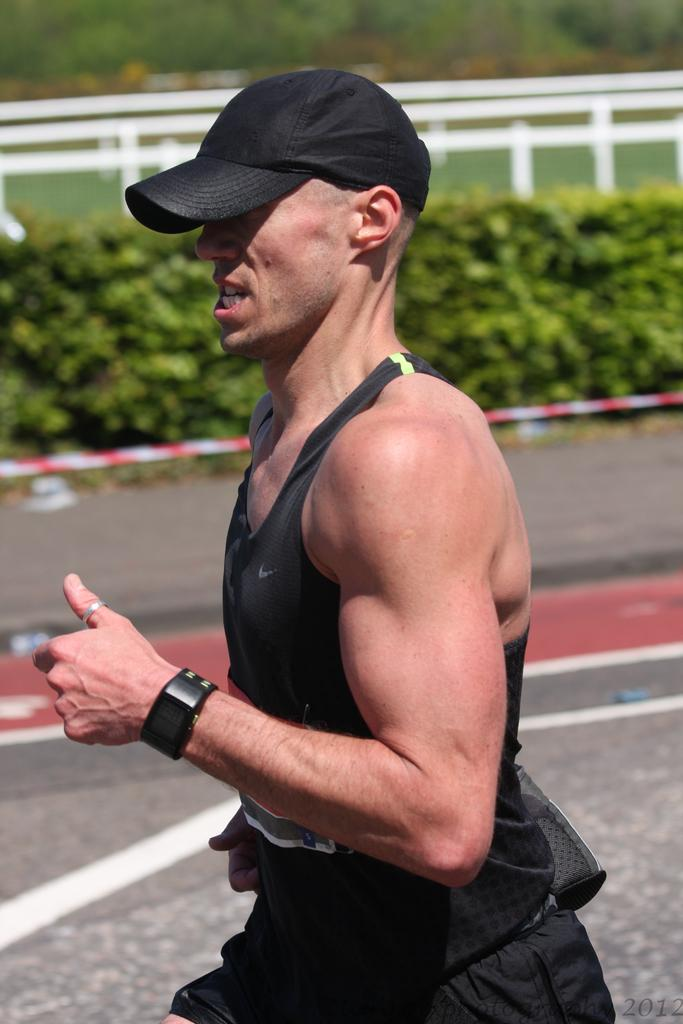Who is present in the image? There is a person in the image. What is the person wearing on their head? The person is wearing a cap. What is the person doing in the image? The person is running. What type of vegetation can be seen in the image? There are plants visible in the image. What type of drink is the person holding in the image? There is no drink visible in the image; the person is running and wearing a cap. How many girls are present in the image? The image only features one person, who is not identified as a girl. 